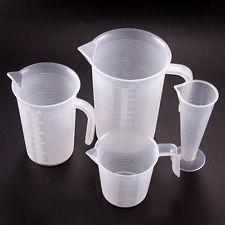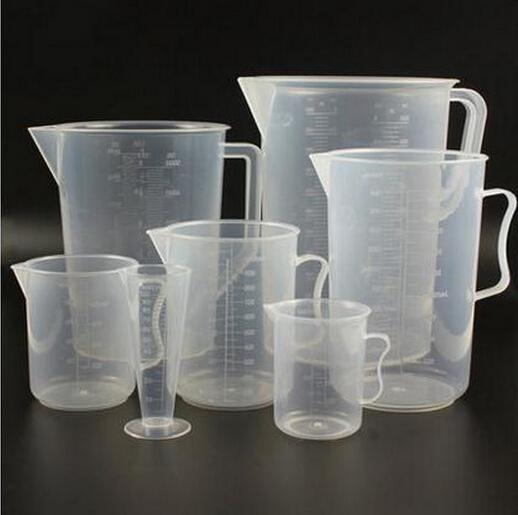The first image is the image on the left, the second image is the image on the right. Given the left and right images, does the statement "One of the images contains exactly five measuring cups." hold true? Answer yes or no. No. 